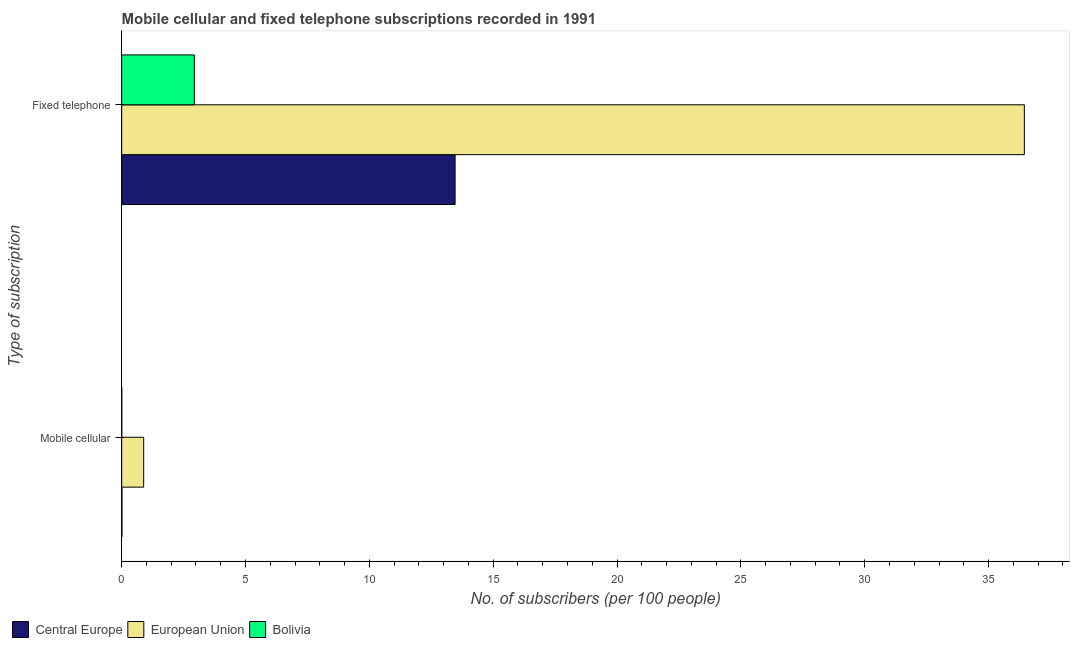Are the number of bars per tick equal to the number of legend labels?
Make the answer very short. Yes. Are the number of bars on each tick of the Y-axis equal?
Provide a succinct answer. Yes. How many bars are there on the 1st tick from the top?
Your answer should be compact. 3. How many bars are there on the 1st tick from the bottom?
Offer a terse response. 3. What is the label of the 2nd group of bars from the top?
Offer a very short reply. Mobile cellular. What is the number of fixed telephone subscribers in Bolivia?
Your response must be concise. 2.93. Across all countries, what is the maximum number of mobile cellular subscribers?
Ensure brevity in your answer.  0.89. Across all countries, what is the minimum number of mobile cellular subscribers?
Provide a succinct answer. 0. In which country was the number of fixed telephone subscribers maximum?
Ensure brevity in your answer.  European Union. In which country was the number of mobile cellular subscribers minimum?
Give a very brief answer. Bolivia. What is the total number of mobile cellular subscribers in the graph?
Keep it short and to the point. 0.9. What is the difference between the number of fixed telephone subscribers in European Union and that in Central Europe?
Give a very brief answer. 22.98. What is the difference between the number of mobile cellular subscribers in European Union and the number of fixed telephone subscribers in Central Europe?
Provide a short and direct response. -12.57. What is the average number of mobile cellular subscribers per country?
Your answer should be very brief. 0.3. What is the difference between the number of fixed telephone subscribers and number of mobile cellular subscribers in Central Europe?
Give a very brief answer. 13.45. In how many countries, is the number of mobile cellular subscribers greater than 21 ?
Your response must be concise. 0. What is the ratio of the number of mobile cellular subscribers in Bolivia to that in Central Europe?
Give a very brief answer. 0.36. In how many countries, is the number of fixed telephone subscribers greater than the average number of fixed telephone subscribers taken over all countries?
Give a very brief answer. 1. What does the 3rd bar from the top in Mobile cellular represents?
Your response must be concise. Central Europe. What does the 1st bar from the bottom in Mobile cellular represents?
Ensure brevity in your answer.  Central Europe. What is the difference between two consecutive major ticks on the X-axis?
Ensure brevity in your answer.  5. Does the graph contain any zero values?
Give a very brief answer. No. Does the graph contain grids?
Your answer should be compact. No. How many legend labels are there?
Ensure brevity in your answer.  3. How are the legend labels stacked?
Your response must be concise. Horizontal. What is the title of the graph?
Provide a short and direct response. Mobile cellular and fixed telephone subscriptions recorded in 1991. Does "Thailand" appear as one of the legend labels in the graph?
Give a very brief answer. No. What is the label or title of the X-axis?
Your answer should be very brief. No. of subscribers (per 100 people). What is the label or title of the Y-axis?
Your answer should be compact. Type of subscription. What is the No. of subscribers (per 100 people) in Central Europe in Mobile cellular?
Provide a succinct answer. 0.01. What is the No. of subscribers (per 100 people) in European Union in Mobile cellular?
Offer a very short reply. 0.89. What is the No. of subscribers (per 100 people) in Bolivia in Mobile cellular?
Ensure brevity in your answer.  0. What is the No. of subscribers (per 100 people) of Central Europe in Fixed telephone?
Keep it short and to the point. 13.46. What is the No. of subscribers (per 100 people) in European Union in Fixed telephone?
Provide a succinct answer. 36.45. What is the No. of subscribers (per 100 people) of Bolivia in Fixed telephone?
Your answer should be very brief. 2.93. Across all Type of subscription, what is the maximum No. of subscribers (per 100 people) in Central Europe?
Provide a succinct answer. 13.46. Across all Type of subscription, what is the maximum No. of subscribers (per 100 people) in European Union?
Make the answer very short. 36.45. Across all Type of subscription, what is the maximum No. of subscribers (per 100 people) in Bolivia?
Your response must be concise. 2.93. Across all Type of subscription, what is the minimum No. of subscribers (per 100 people) of Central Europe?
Offer a very short reply. 0.01. Across all Type of subscription, what is the minimum No. of subscribers (per 100 people) of European Union?
Offer a terse response. 0.89. Across all Type of subscription, what is the minimum No. of subscribers (per 100 people) in Bolivia?
Ensure brevity in your answer.  0. What is the total No. of subscribers (per 100 people) of Central Europe in the graph?
Your answer should be very brief. 13.47. What is the total No. of subscribers (per 100 people) in European Union in the graph?
Offer a very short reply. 37.33. What is the total No. of subscribers (per 100 people) of Bolivia in the graph?
Offer a very short reply. 2.94. What is the difference between the No. of subscribers (per 100 people) in Central Europe in Mobile cellular and that in Fixed telephone?
Offer a terse response. -13.45. What is the difference between the No. of subscribers (per 100 people) of European Union in Mobile cellular and that in Fixed telephone?
Ensure brevity in your answer.  -35.56. What is the difference between the No. of subscribers (per 100 people) in Bolivia in Mobile cellular and that in Fixed telephone?
Offer a very short reply. -2.93. What is the difference between the No. of subscribers (per 100 people) in Central Europe in Mobile cellular and the No. of subscribers (per 100 people) in European Union in Fixed telephone?
Offer a very short reply. -36.43. What is the difference between the No. of subscribers (per 100 people) of Central Europe in Mobile cellular and the No. of subscribers (per 100 people) of Bolivia in Fixed telephone?
Offer a very short reply. -2.92. What is the difference between the No. of subscribers (per 100 people) of European Union in Mobile cellular and the No. of subscribers (per 100 people) of Bolivia in Fixed telephone?
Your answer should be compact. -2.05. What is the average No. of subscribers (per 100 people) in Central Europe per Type of subscription?
Make the answer very short. 6.74. What is the average No. of subscribers (per 100 people) in European Union per Type of subscription?
Offer a terse response. 18.67. What is the average No. of subscribers (per 100 people) of Bolivia per Type of subscription?
Ensure brevity in your answer.  1.47. What is the difference between the No. of subscribers (per 100 people) in Central Europe and No. of subscribers (per 100 people) in European Union in Mobile cellular?
Your answer should be very brief. -0.88. What is the difference between the No. of subscribers (per 100 people) of Central Europe and No. of subscribers (per 100 people) of Bolivia in Mobile cellular?
Offer a very short reply. 0.01. What is the difference between the No. of subscribers (per 100 people) in European Union and No. of subscribers (per 100 people) in Bolivia in Mobile cellular?
Provide a succinct answer. 0.88. What is the difference between the No. of subscribers (per 100 people) of Central Europe and No. of subscribers (per 100 people) of European Union in Fixed telephone?
Provide a succinct answer. -22.98. What is the difference between the No. of subscribers (per 100 people) in Central Europe and No. of subscribers (per 100 people) in Bolivia in Fixed telephone?
Your response must be concise. 10.53. What is the difference between the No. of subscribers (per 100 people) of European Union and No. of subscribers (per 100 people) of Bolivia in Fixed telephone?
Offer a very short reply. 33.51. What is the ratio of the No. of subscribers (per 100 people) of Central Europe in Mobile cellular to that in Fixed telephone?
Provide a short and direct response. 0. What is the ratio of the No. of subscribers (per 100 people) of European Union in Mobile cellular to that in Fixed telephone?
Your answer should be very brief. 0.02. What is the ratio of the No. of subscribers (per 100 people) of Bolivia in Mobile cellular to that in Fixed telephone?
Your answer should be very brief. 0. What is the difference between the highest and the second highest No. of subscribers (per 100 people) in Central Europe?
Make the answer very short. 13.45. What is the difference between the highest and the second highest No. of subscribers (per 100 people) of European Union?
Give a very brief answer. 35.56. What is the difference between the highest and the second highest No. of subscribers (per 100 people) of Bolivia?
Ensure brevity in your answer.  2.93. What is the difference between the highest and the lowest No. of subscribers (per 100 people) in Central Europe?
Make the answer very short. 13.45. What is the difference between the highest and the lowest No. of subscribers (per 100 people) in European Union?
Ensure brevity in your answer.  35.56. What is the difference between the highest and the lowest No. of subscribers (per 100 people) in Bolivia?
Keep it short and to the point. 2.93. 